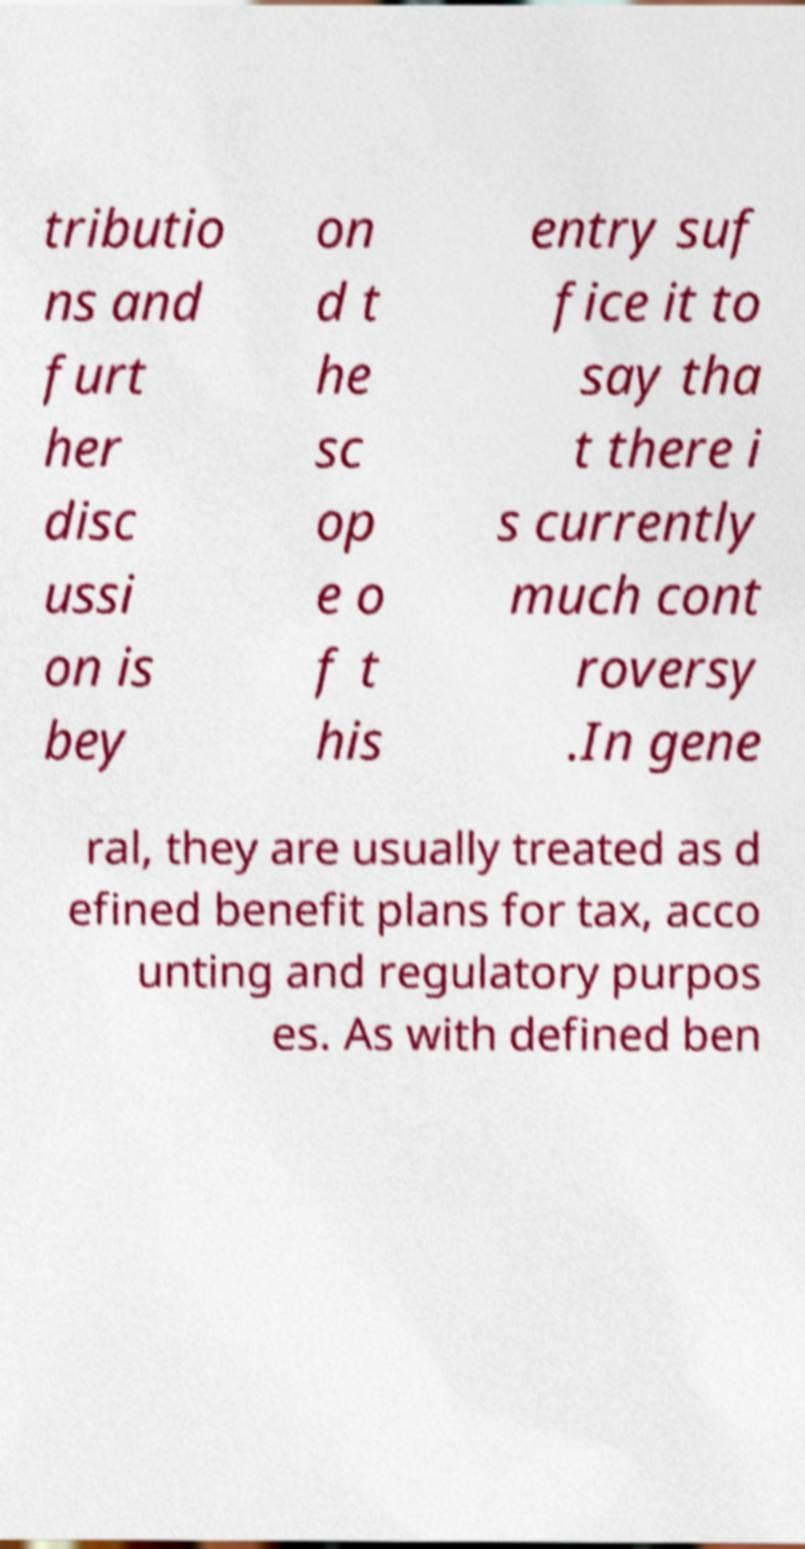Please read and relay the text visible in this image. What does it say? tributio ns and furt her disc ussi on is bey on d t he sc op e o f t his entry suf fice it to say tha t there i s currently much cont roversy .In gene ral, they are usually treated as d efined benefit plans for tax, acco unting and regulatory purpos es. As with defined ben 